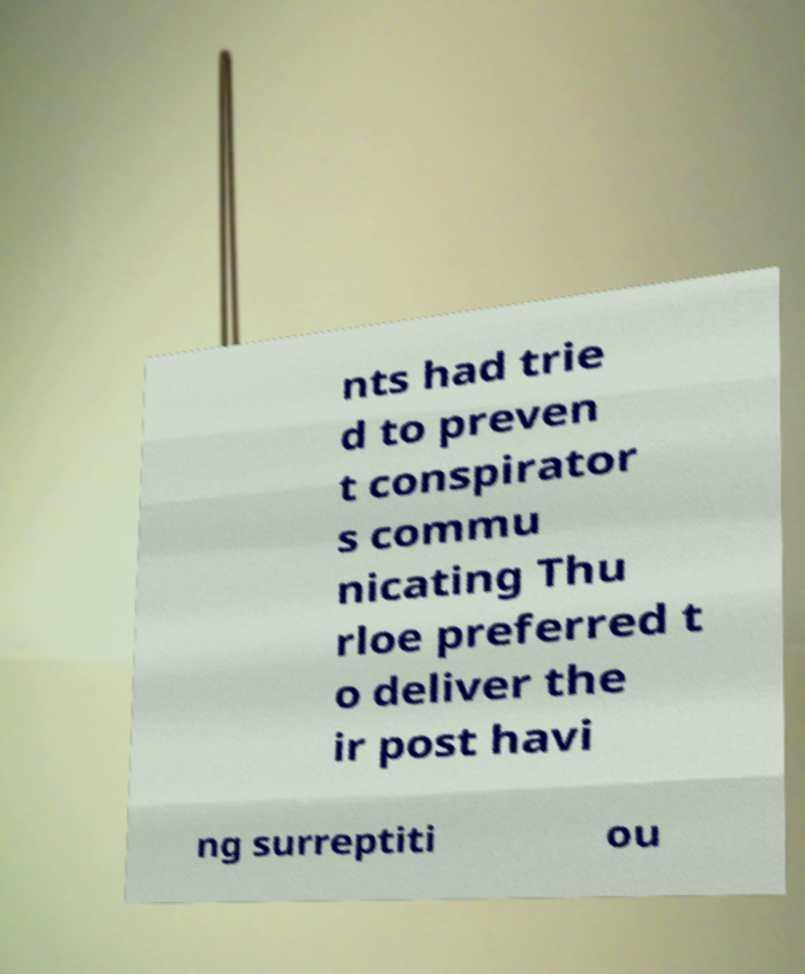There's text embedded in this image that I need extracted. Can you transcribe it verbatim? nts had trie d to preven t conspirator s commu nicating Thu rloe preferred t o deliver the ir post havi ng surreptiti ou 